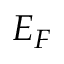<formula> <loc_0><loc_0><loc_500><loc_500>E _ { F }</formula> 